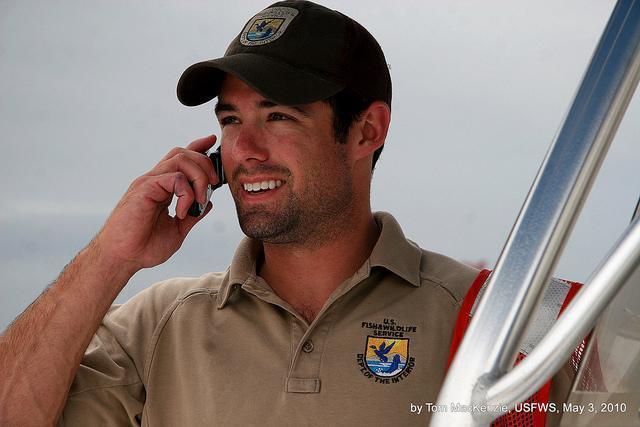How many windows on this airplane are touched by red or orange paint?
Give a very brief answer. 0. 